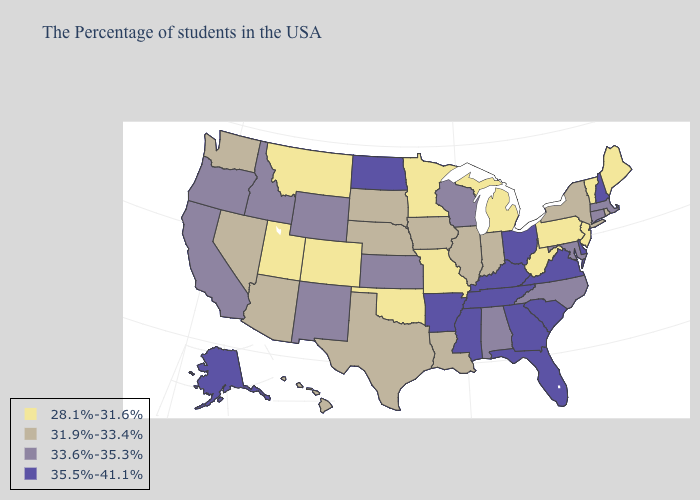Does the first symbol in the legend represent the smallest category?
Write a very short answer. Yes. What is the value of Tennessee?
Answer briefly. 35.5%-41.1%. Which states have the lowest value in the South?
Give a very brief answer. West Virginia, Oklahoma. What is the lowest value in the Northeast?
Concise answer only. 28.1%-31.6%. Name the states that have a value in the range 33.6%-35.3%?
Concise answer only. Massachusetts, Connecticut, Maryland, North Carolina, Alabama, Wisconsin, Kansas, Wyoming, New Mexico, Idaho, California, Oregon. Among the states that border Kansas , which have the highest value?
Answer briefly. Nebraska. What is the lowest value in states that border Wisconsin?
Quick response, please. 28.1%-31.6%. Is the legend a continuous bar?
Answer briefly. No. What is the highest value in the South ?
Give a very brief answer. 35.5%-41.1%. Among the states that border Georgia , which have the lowest value?
Be succinct. North Carolina, Alabama. What is the value of Oklahoma?
Write a very short answer. 28.1%-31.6%. Name the states that have a value in the range 28.1%-31.6%?
Write a very short answer. Maine, Vermont, New Jersey, Pennsylvania, West Virginia, Michigan, Missouri, Minnesota, Oklahoma, Colorado, Utah, Montana. Name the states that have a value in the range 35.5%-41.1%?
Write a very short answer. New Hampshire, Delaware, Virginia, South Carolina, Ohio, Florida, Georgia, Kentucky, Tennessee, Mississippi, Arkansas, North Dakota, Alaska. What is the value of Georgia?
Short answer required. 35.5%-41.1%. Among the states that border South Carolina , which have the highest value?
Give a very brief answer. Georgia. 